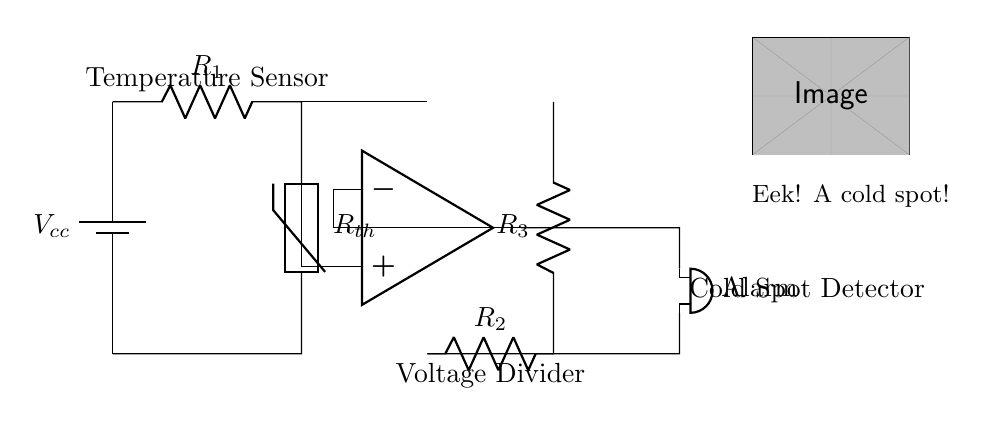What is the power supply type in this circuit? The circuit uses a battery, as indicated by the symbol for the battery at the top left.
Answer: Battery What component acts as the temperature sensor in this diagram? The thermistor is the component responsible for detecting temperature changes, clearly labeled in the circuit.
Answer: Thermistor What is the purpose of the operational amplifier in this circuit? The operational amplifier compares the voltage from the thermistor to a reference voltage, allowing for the detection of cold spots based on output changes.
Answer: Comparison What components form the voltage divider in this circuit? The resistors labeled as R2 and R3 create the voltage divider configuration which sets the reference voltage for the op-amp.
Answer: R2 and R3 How does the alarm get activated in this circuit? When the temperature detected by the thermistor falls below a certain threshold, the op-amp output changes state, triggering the buzzer to sound the alarm.
Answer: Buzzer What does the cold spot detector label refer to in the circuit? The label indicates the overall function of the circuit, focusing on monitoring for temperature drops indicating cold spots in a paranormal context.
Answer: Cold Spot Detector What is the function of R1 in the temperature-sensitive alarm circuit? R1, the resistor in series with the thermistor, helps to limit current and sets up a voltage drop that can be measured for changes in temperature.
Answer: Current Limiter 